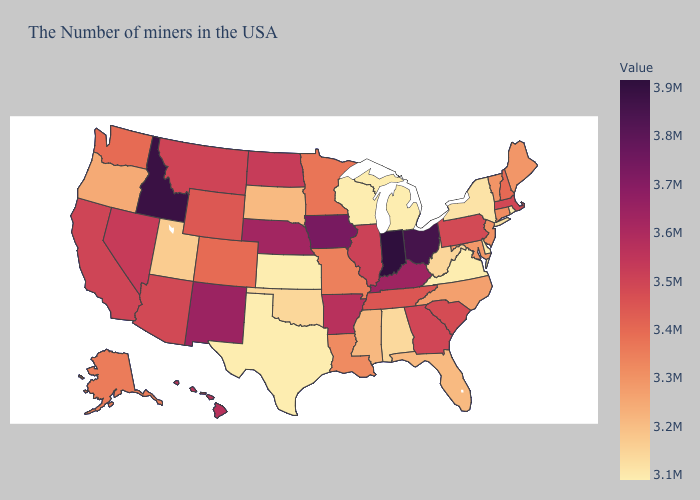Among the states that border Alabama , which have the lowest value?
Write a very short answer. Florida. Does Idaho have the highest value in the West?
Quick response, please. Yes. Does Tennessee have a lower value than Alaska?
Keep it brief. No. Does Minnesota have a lower value than Virginia?
Keep it brief. No. Which states have the lowest value in the MidWest?
Keep it brief. Michigan, Wisconsin, Kansas. Which states have the lowest value in the USA?
Concise answer only. Rhode Island, Delaware, Virginia, Michigan, Wisconsin, Kansas, Texas. 